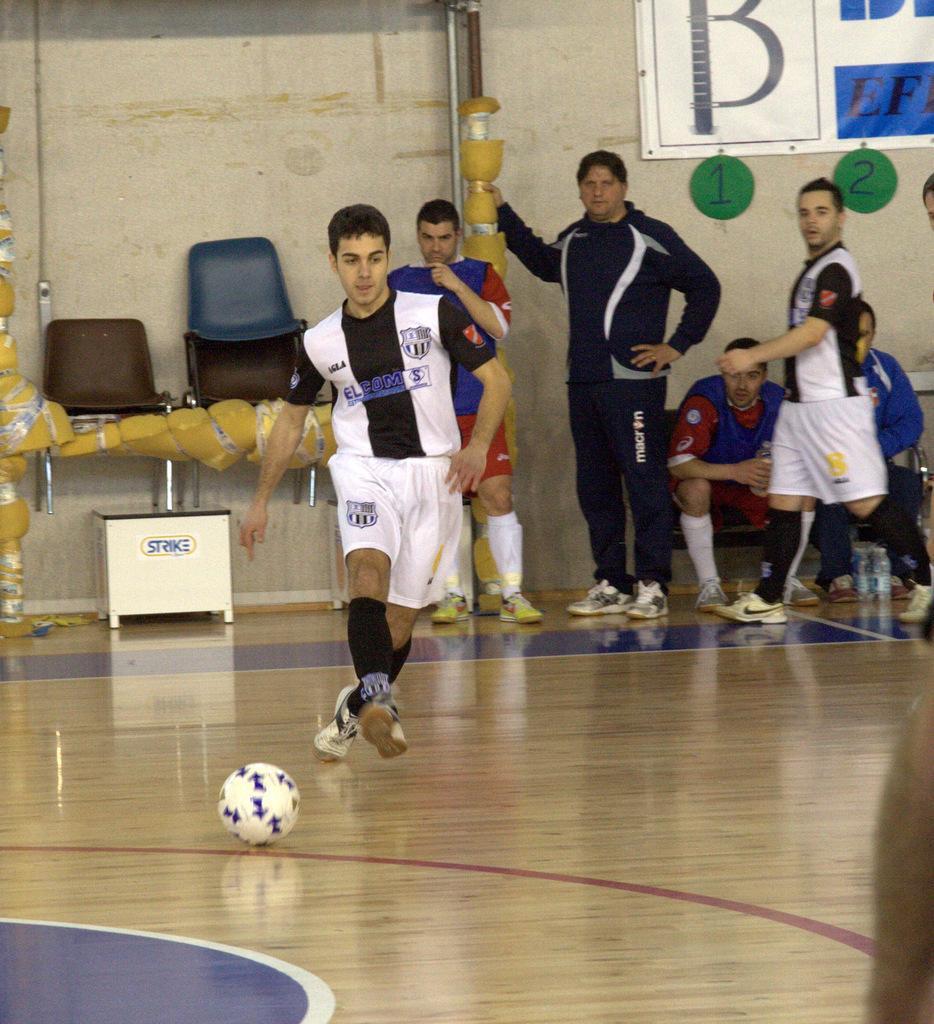In one or two sentences, can you explain what this image depicts? In this picture we can see a ball, chairs and a man running on the ground and in the background we can see a group of people, bottles, banner on the wall. 